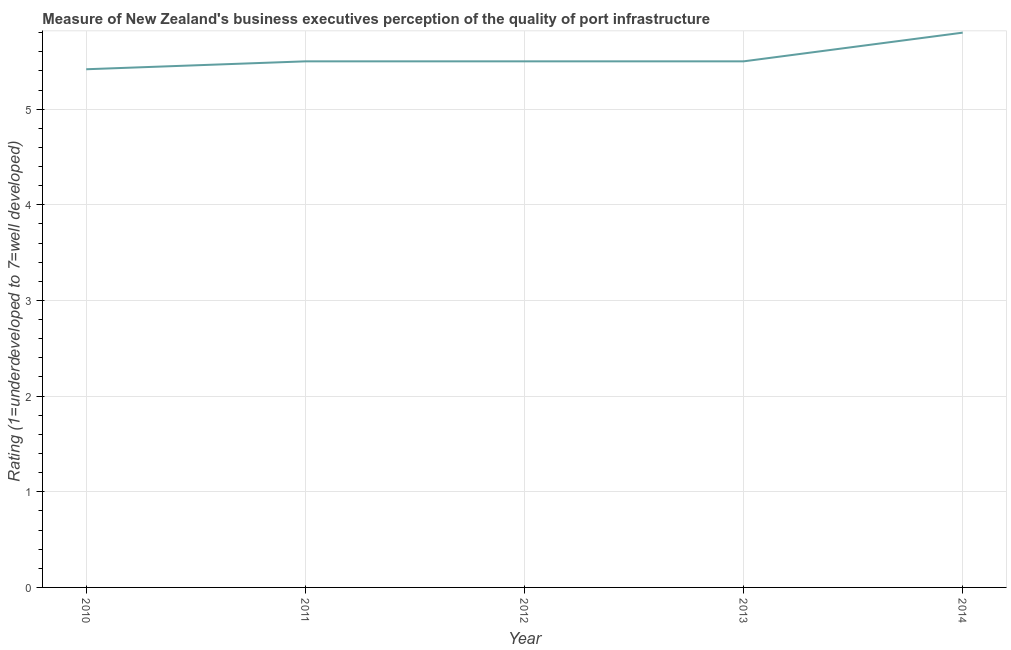What is the rating measuring quality of port infrastructure in 2014?
Your answer should be compact. 5.8. Across all years, what is the maximum rating measuring quality of port infrastructure?
Ensure brevity in your answer.  5.8. Across all years, what is the minimum rating measuring quality of port infrastructure?
Make the answer very short. 5.42. In which year was the rating measuring quality of port infrastructure maximum?
Offer a very short reply. 2014. In which year was the rating measuring quality of port infrastructure minimum?
Your answer should be compact. 2010. What is the sum of the rating measuring quality of port infrastructure?
Your response must be concise. 27.72. What is the difference between the rating measuring quality of port infrastructure in 2010 and 2014?
Provide a succinct answer. -0.38. What is the average rating measuring quality of port infrastructure per year?
Give a very brief answer. 5.54. Do a majority of the years between 2013 and 2012 (inclusive) have rating measuring quality of port infrastructure greater than 3.4 ?
Provide a short and direct response. No. What is the ratio of the rating measuring quality of port infrastructure in 2013 to that in 2014?
Provide a succinct answer. 0.95. Is the difference between the rating measuring quality of port infrastructure in 2012 and 2014 greater than the difference between any two years?
Offer a terse response. No. What is the difference between the highest and the second highest rating measuring quality of port infrastructure?
Ensure brevity in your answer.  0.3. Is the sum of the rating measuring quality of port infrastructure in 2010 and 2013 greater than the maximum rating measuring quality of port infrastructure across all years?
Offer a very short reply. Yes. What is the difference between the highest and the lowest rating measuring quality of port infrastructure?
Your response must be concise. 0.38. How many years are there in the graph?
Your answer should be very brief. 5. What is the title of the graph?
Your response must be concise. Measure of New Zealand's business executives perception of the quality of port infrastructure. What is the label or title of the X-axis?
Ensure brevity in your answer.  Year. What is the label or title of the Y-axis?
Provide a short and direct response. Rating (1=underdeveloped to 7=well developed) . What is the Rating (1=underdeveloped to 7=well developed)  of 2010?
Ensure brevity in your answer.  5.42. What is the Rating (1=underdeveloped to 7=well developed)  in 2011?
Ensure brevity in your answer.  5.5. What is the difference between the Rating (1=underdeveloped to 7=well developed)  in 2010 and 2011?
Provide a succinct answer. -0.08. What is the difference between the Rating (1=underdeveloped to 7=well developed)  in 2010 and 2012?
Make the answer very short. -0.08. What is the difference between the Rating (1=underdeveloped to 7=well developed)  in 2010 and 2013?
Make the answer very short. -0.08. What is the difference between the Rating (1=underdeveloped to 7=well developed)  in 2010 and 2014?
Provide a succinct answer. -0.38. What is the difference between the Rating (1=underdeveloped to 7=well developed)  in 2011 and 2013?
Keep it short and to the point. 0. What is the difference between the Rating (1=underdeveloped to 7=well developed)  in 2012 and 2013?
Provide a succinct answer. 0. What is the ratio of the Rating (1=underdeveloped to 7=well developed)  in 2010 to that in 2012?
Keep it short and to the point. 0.98. What is the ratio of the Rating (1=underdeveloped to 7=well developed)  in 2010 to that in 2014?
Your response must be concise. 0.93. What is the ratio of the Rating (1=underdeveloped to 7=well developed)  in 2011 to that in 2012?
Your answer should be compact. 1. What is the ratio of the Rating (1=underdeveloped to 7=well developed)  in 2011 to that in 2014?
Give a very brief answer. 0.95. What is the ratio of the Rating (1=underdeveloped to 7=well developed)  in 2012 to that in 2013?
Your response must be concise. 1. What is the ratio of the Rating (1=underdeveloped to 7=well developed)  in 2012 to that in 2014?
Your answer should be compact. 0.95. What is the ratio of the Rating (1=underdeveloped to 7=well developed)  in 2013 to that in 2014?
Offer a terse response. 0.95. 